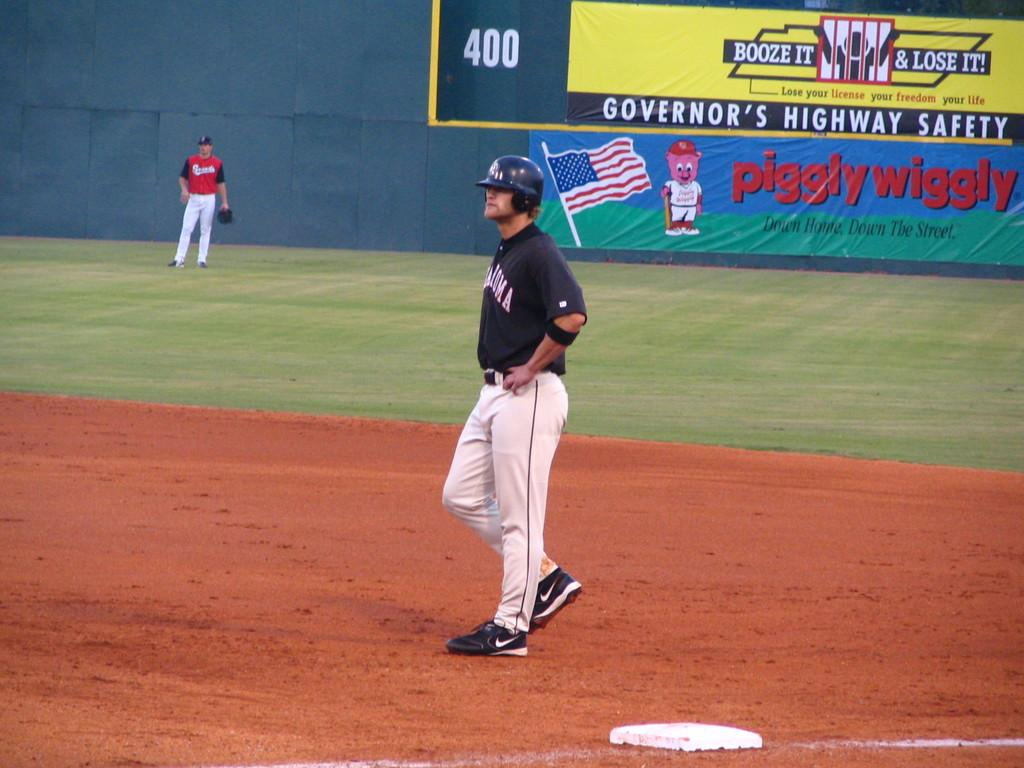<image>
Render a clear and concise summary of the photo. A baseball player is standing near first base with his hands on his hips in front of a piggly wiggly store advertising banner. 